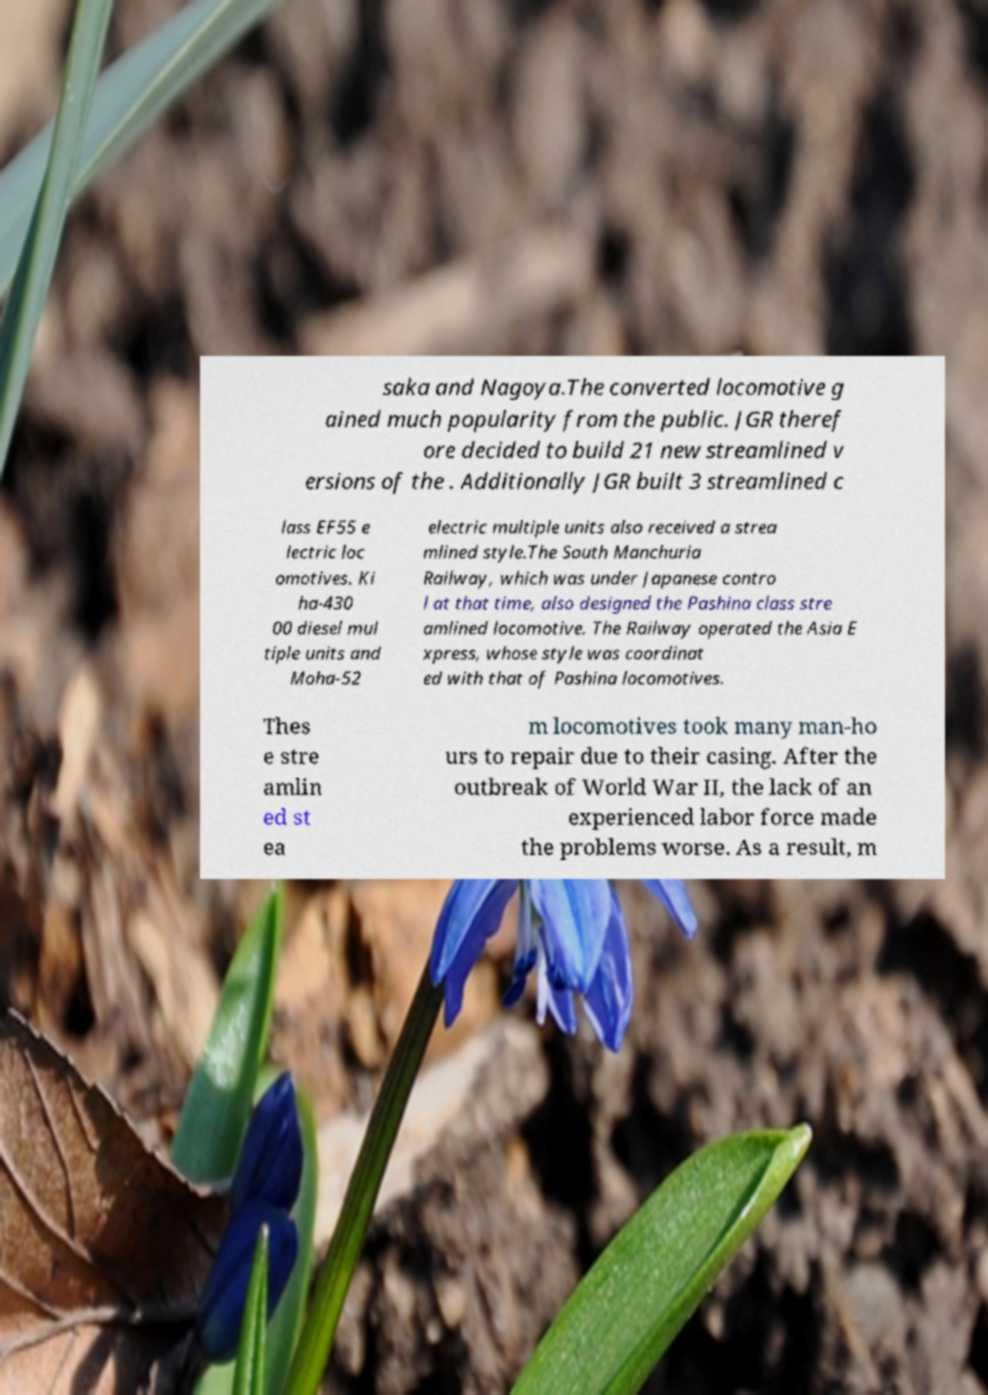Could you extract and type out the text from this image? saka and Nagoya.The converted locomotive g ained much popularity from the public. JGR theref ore decided to build 21 new streamlined v ersions of the . Additionally JGR built 3 streamlined c lass EF55 e lectric loc omotives. Ki ha-430 00 diesel mul tiple units and Moha-52 electric multiple units also received a strea mlined style.The South Manchuria Railway, which was under Japanese contro l at that time, also designed the Pashina class stre amlined locomotive. The Railway operated the Asia E xpress, whose style was coordinat ed with that of Pashina locomotives. Thes e stre amlin ed st ea m locomotives took many man-ho urs to repair due to their casing. After the outbreak of World War II, the lack of an experienced labor force made the problems worse. As a result, m 